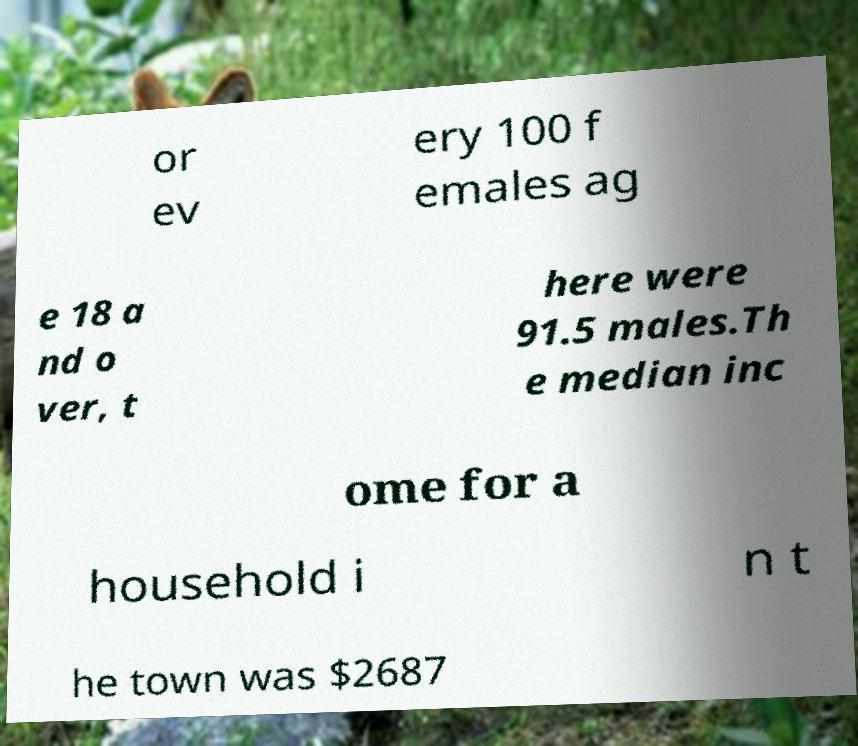I need the written content from this picture converted into text. Can you do that? or ev ery 100 f emales ag e 18 a nd o ver, t here were 91.5 males.Th e median inc ome for a household i n t he town was $2687 